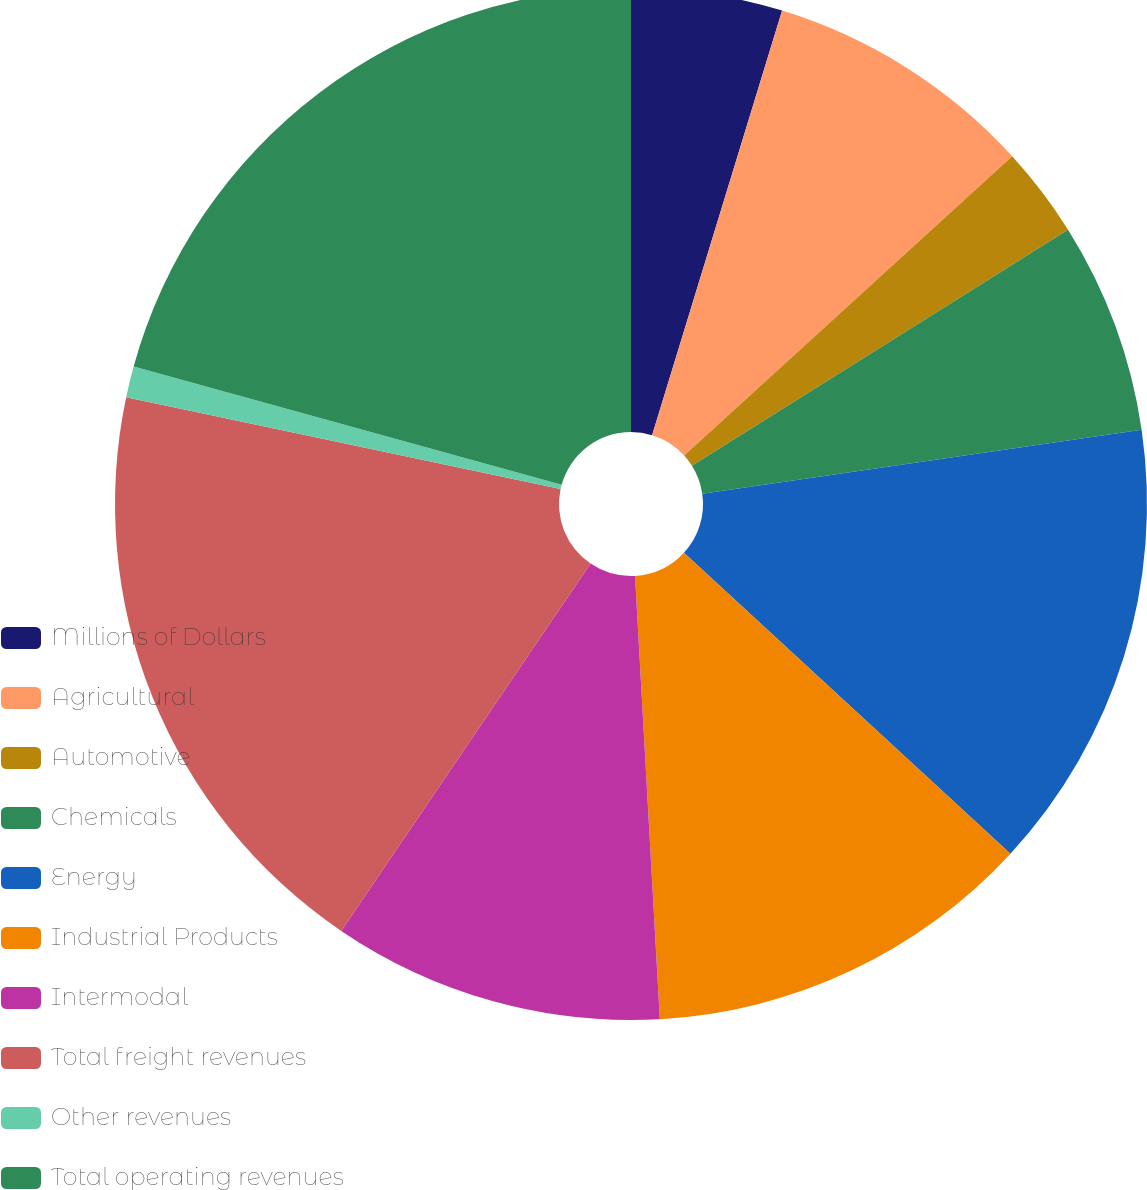Convert chart. <chart><loc_0><loc_0><loc_500><loc_500><pie_chart><fcel>Millions of Dollars<fcel>Agricultural<fcel>Automotive<fcel>Chemicals<fcel>Energy<fcel>Industrial Products<fcel>Intermodal<fcel>Total freight revenues<fcel>Other revenues<fcel>Total operating revenues<nl><fcel>4.73%<fcel>8.5%<fcel>2.85%<fcel>6.62%<fcel>14.15%<fcel>12.26%<fcel>10.38%<fcel>18.83%<fcel>0.97%<fcel>20.71%<nl></chart> 